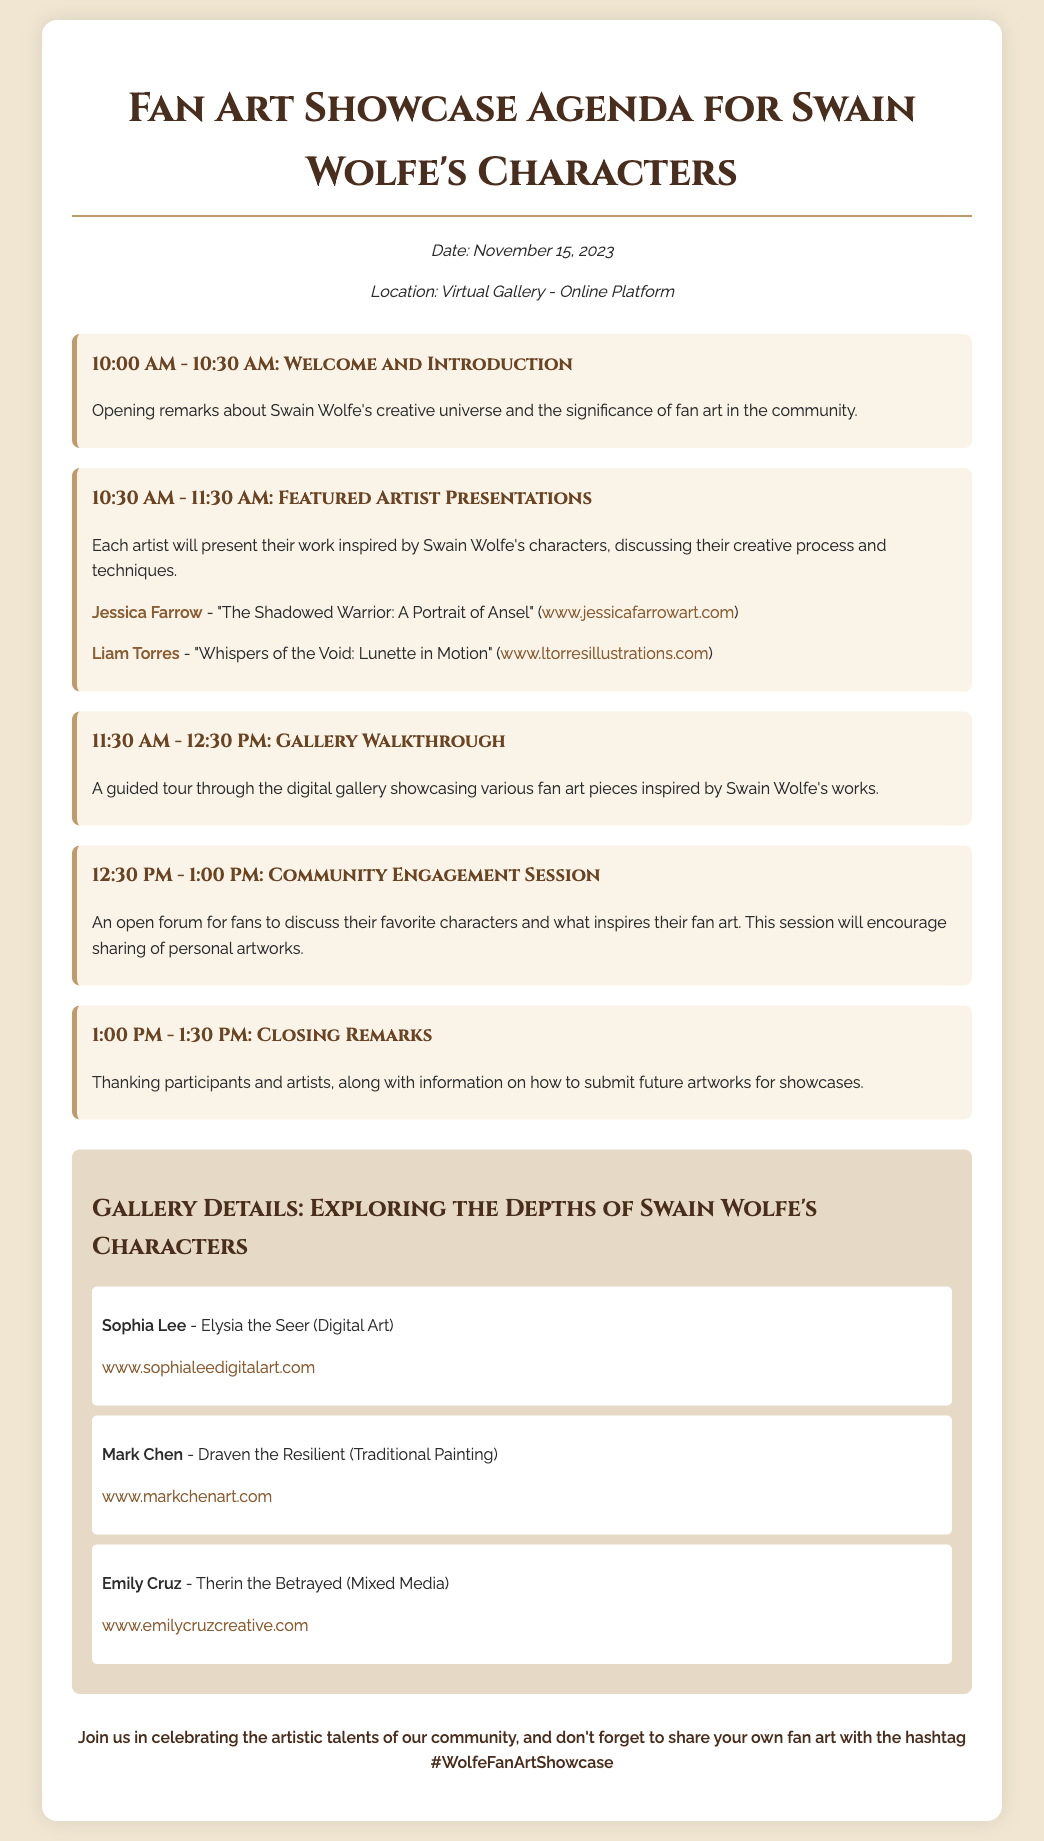What is the date of the event? The date of the event is specified in the document under the event details section.
Answer: November 15, 2023 Who is the first featured artist presenting? The first featured artist is mentioned in the schedule item for the Featured Artist Presentations.
Answer: Jessica Farrow What is the title of Liam Torres’s artwork? The title is referenced in the schedule item discussing the Featured Artist Presentations.
Answer: Whispers of the Void: Lunette in Motion How long is the Community Engagement Session? The duration of this session is indicated in the schedule section.
Answer: 30 minutes What type of art does Mark Chen create? This information can be found in the gallery details related to artist Mark Chen.
Answer: Traditional Painting What is the purpose of the Opening remarks? The purpose is described in the first schedule item as it relates to the community and the event itself.
Answer: To discuss Swain Wolfe's creative universe What time does the Gallery Walkthrough start? The time for the Gallery Walkthrough is mentioned in the schedule.
Answer: 11:30 AM What is the online platform for the event? The platform is referenced in the event details section but is not explicitly named. This question checks for understanding of terms.
Answer: Virtual Gallery What should participants use to share their artworks? The call-to-action section emphasizes how participants can share their artworks online.
Answer: #WolfeFanArtShowcase 